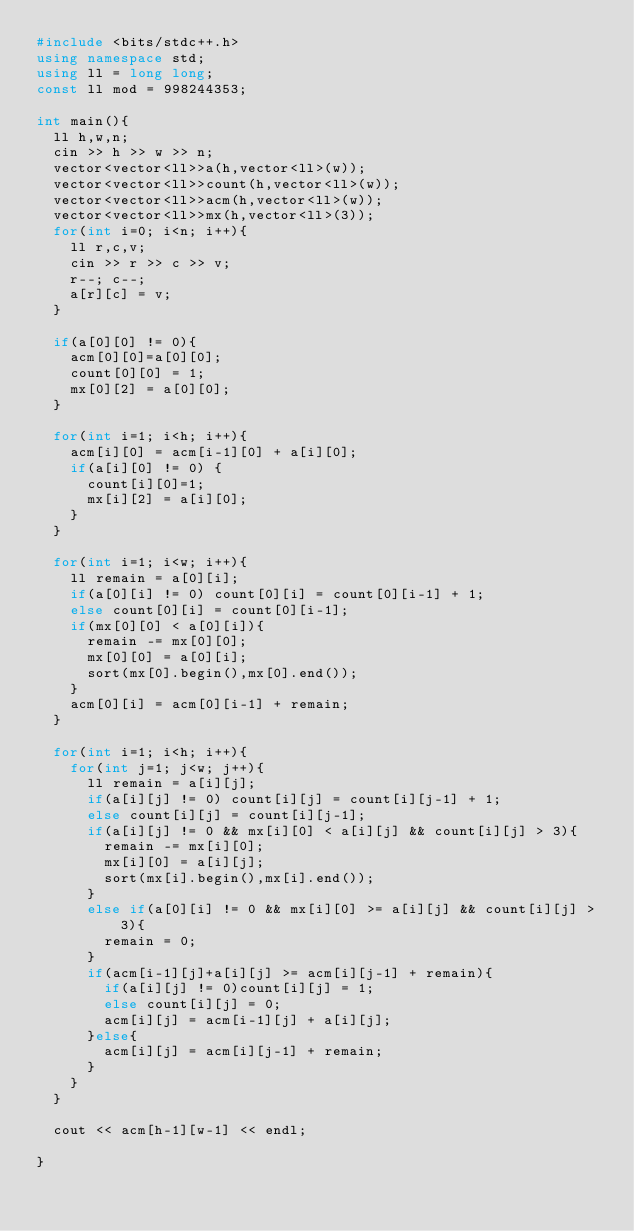<code> <loc_0><loc_0><loc_500><loc_500><_C++_>#include <bits/stdc++.h>
using namespace std;
using ll = long long;
const ll mod = 998244353;

int main(){
  ll h,w,n;
  cin >> h >> w >> n;
  vector<vector<ll>>a(h,vector<ll>(w));
  vector<vector<ll>>count(h,vector<ll>(w));
  vector<vector<ll>>acm(h,vector<ll>(w));
  vector<vector<ll>>mx(h,vector<ll>(3));
  for(int i=0; i<n; i++){
    ll r,c,v;
    cin >> r >> c >> v;
    r--; c--;
    a[r][c] = v;
  }
  
  if(a[0][0] != 0){
    acm[0][0]=a[0][0];
    count[0][0] = 1;
    mx[0][2] = a[0][0];
  }
  
  for(int i=1; i<h; i++){
    acm[i][0] = acm[i-1][0] + a[i][0];
    if(a[i][0] != 0) {
      count[i][0]=1;
      mx[i][2] = a[i][0];
    }
  }
  
  for(int i=1; i<w; i++){
    ll remain = a[0][i];
    if(a[0][i] != 0) count[0][i] = count[0][i-1] + 1;
    else count[0][i] = count[0][i-1];
    if(mx[0][0] < a[0][i]){
      remain -= mx[0][0];
      mx[0][0] = a[0][i];
      sort(mx[0].begin(),mx[0].end());
    }
    acm[0][i] = acm[0][i-1] + remain;
  }
  
  for(int i=1; i<h; i++){
    for(int j=1; j<w; j++){
      ll remain = a[i][j];
      if(a[i][j] != 0) count[i][j] = count[i][j-1] + 1;
      else count[i][j] = count[i][j-1];
      if(a[i][j] != 0 && mx[i][0] < a[i][j] && count[i][j] > 3){
        remain -= mx[i][0];
        mx[i][0] = a[i][j];
        sort(mx[i].begin(),mx[i].end());
      }
      else if(a[0][i] != 0 && mx[i][0] >= a[i][j] && count[i][j] > 3){
        remain = 0;
      }
      if(acm[i-1][j]+a[i][j] >= acm[i][j-1] + remain){
        if(a[i][j] != 0)count[i][j] = 1;
        else count[i][j] = 0;
        acm[i][j] = acm[i-1][j] + a[i][j];
      }else{
        acm[i][j] = acm[i][j-1] + remain;
      }
    }
  }
  
  cout << acm[h-1][w-1] << endl;
  
}
</code> 